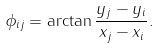Convert formula to latex. <formula><loc_0><loc_0><loc_500><loc_500>\phi _ { i j } = \arctan { \frac { y _ { j } - y _ { i } } { x _ { j } - x _ { i } } } .</formula> 